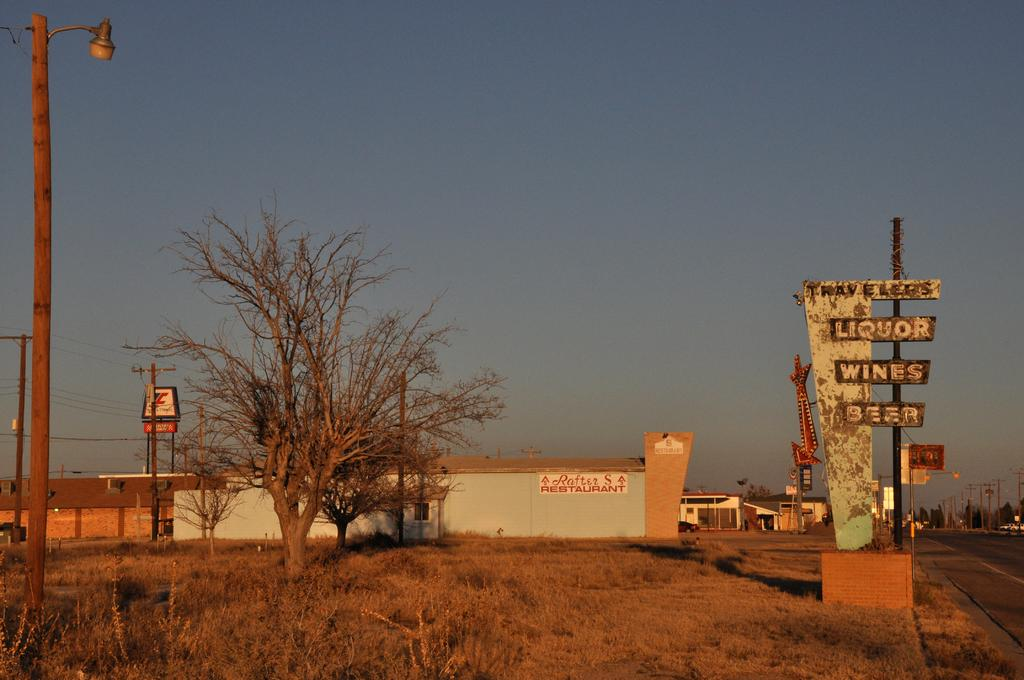What structures can be seen in the image? There are poles, trees, boards, and houses in the image. What type of area is depicted in the image? This is a road. What is visible in the background of the image? There is sky visible in the background of the image. What type of regret can be seen on the faces of the people in the image? There are no people present in the image, so it is not possible to determine if they are experiencing regret. Can you tell me how many items are in the pocket of the person in the image? There is no person present in the image, so it is not possible to determine if they have a pocket or what items might be inside. 